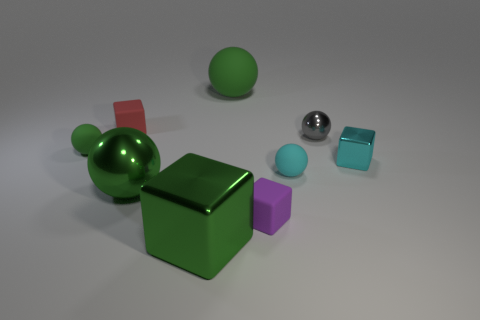How do the colors of the objects interact with each other? The colors of the objects provide a visually stimulating contrast and balance. The vivid green of the large cube and small sphere commands attention at the center of the image. This green is complemented by the calm cyan of the two smaller cubes on the right. The purple cube's mild hue softly contrasts with the nearby cyan, and the bold red of the left cube stands out as an accent color. The silver metal ball and the smaller green sphere add neutral touches, highlighted by the light, that brings variety without overwhelming the color scheme. 